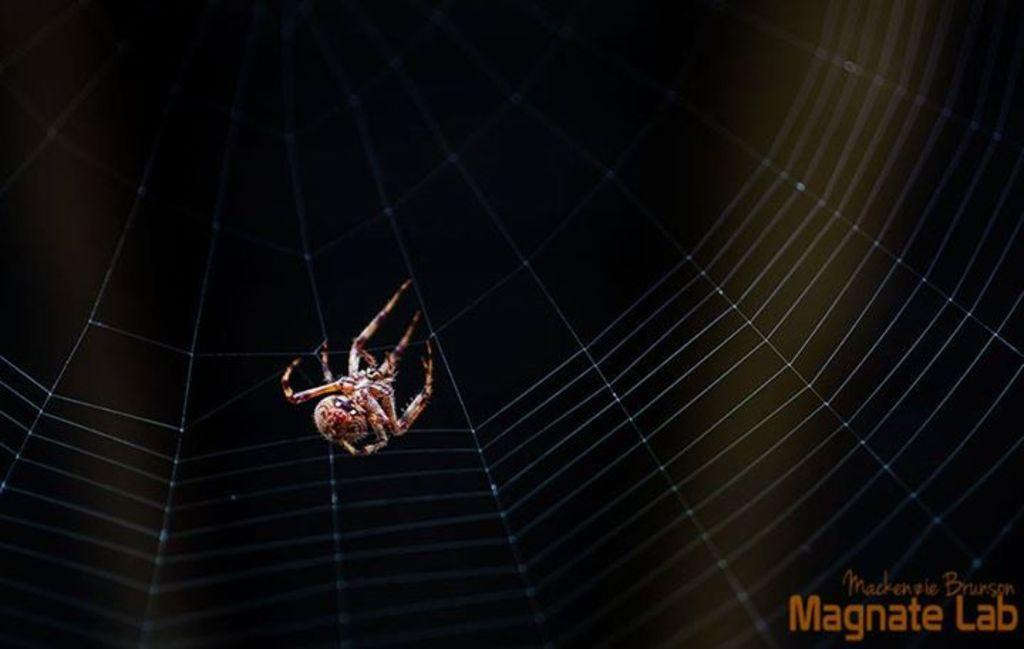What is the main subject of the image? The main subject of the image is a spider. What is associated with the spider in the image? There is a spider web in the image. Is there any text present in the image? Yes, there is some text on the right bottom of the image. What type of produce can be seen hanging from the spider web in the image? There is no produce present in the image; it features a spider and a spider web. How many bones are visible in the image? There are no bones visible in the image. 